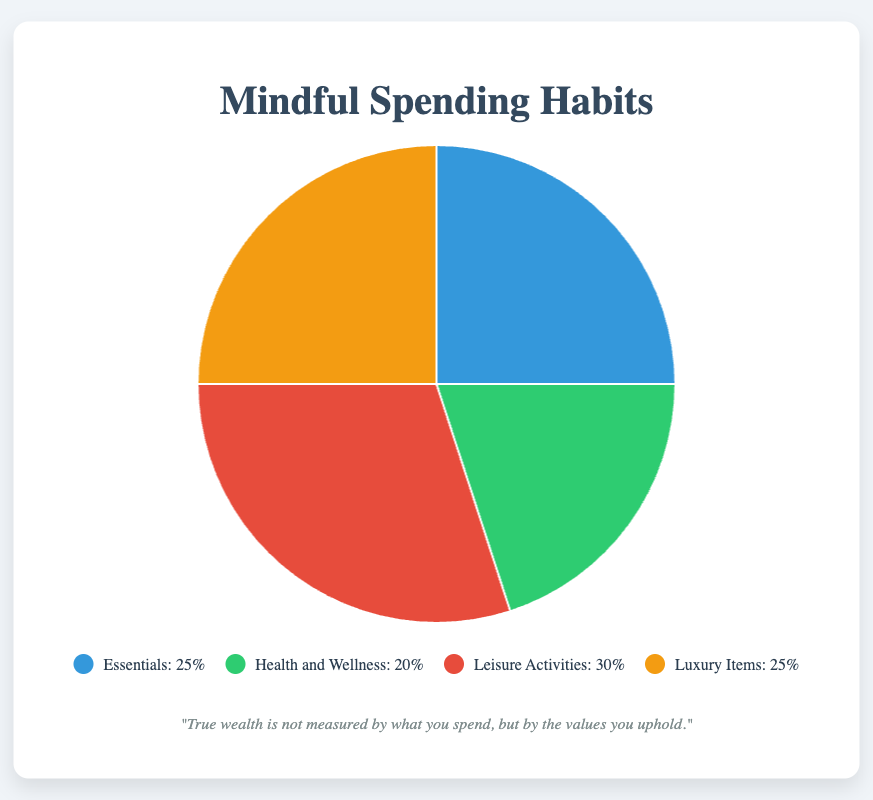what category has the highest percentage of daily spending? The chart shows four categories with their percentages. "Leisure Activities" has the highest value at 30%.
Answer: Leisure Activities which category shares an equal percentage of daily spending? Both "Essentials" and "Luxury Items" have a 25% share.
Answer: Essentials and Luxury Items what is the combined percentage of "Health and Wellness" and "Luxury Items"? Add the percentages of "Health and Wellness" (20%) and "Luxury Items" (25%). 20 + 25 equals 45.
Answer: 45% how much more is spent on "Leisure Activities" compared to "Health and Wellness"? Subtract the percentage of "Health and Wellness" from "Leisure Activities". 30 - 20 equals 10.
Answer: 10% what percentage of daily spending is on "Essentials" and "Luxury Items" combined? Add the percentages of "Essentials" (25%) and "Luxury Items" (25%). 25 + 25 equals 50.
Answer: 50% which category is visually represented by the color blue? The color blue is used in the chart to represent "Essentials".
Answer: Essentials if spending on "Health and Wellness" were to increase by 5%, what would be the new percentage? Add 5% to the current percentage of "Health and Wellness" (20%). 20 + 5 equals 25%.
Answer: 25% is the sum of the percentages for "Essentials" and "Leisure Activities" greater than 50%? Add the percentages of "Essentials" (25%) and "Leisure Activities" (30%). 25 + 30 equals 55%. Since 55% is greater than 50%, the answer is yes.
Answer: Yes how does the spending on "Luxury Items" compare to "Health and Wellness"? "Luxury Items" has a 25% share, while "Health and Wellness" has a 20% share. Since 25 is greater than 20, more is spent on "Luxury Items".
Answer: More on Luxury Items what is the difference in percentage between the largest and smallest spending categories? The largest category is "Leisure Activities" at 30%, and the smallest is "Health and Wellness" at 20%. Subtract the smallest from the largest: 30 - 20 equals 10.
Answer: 10% 